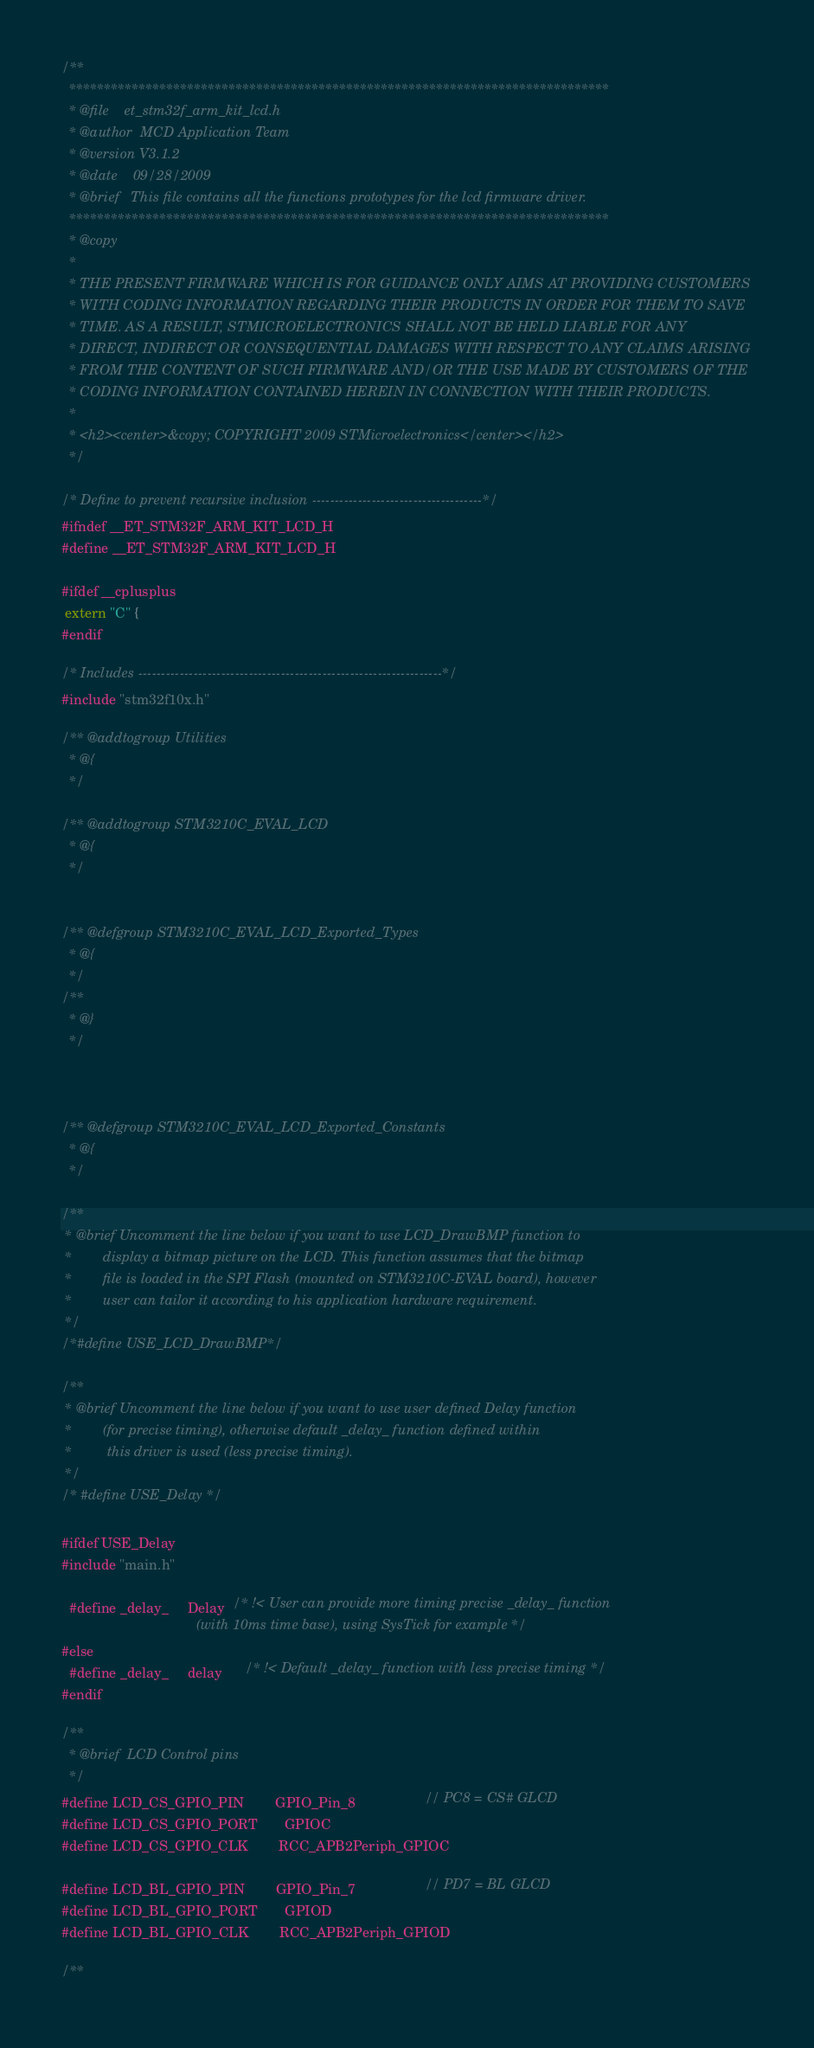Convert code to text. <code><loc_0><loc_0><loc_500><loc_500><_C_>/**
  ******************************************************************************
  * @file    et_stm32f_arm_kit_lcd.h
  * @author  MCD Application Team
  * @version V3.1.2
  * @date    09/28/2009
  * @brief   This file contains all the functions prototypes for the lcd firmware driver.
  ******************************************************************************
  * @copy
  *
  * THE PRESENT FIRMWARE WHICH IS FOR GUIDANCE ONLY AIMS AT PROVIDING CUSTOMERS
  * WITH CODING INFORMATION REGARDING THEIR PRODUCTS IN ORDER FOR THEM TO SAVE
  * TIME. AS A RESULT, STMICROELECTRONICS SHALL NOT BE HELD LIABLE FOR ANY
  * DIRECT, INDIRECT OR CONSEQUENTIAL DAMAGES WITH RESPECT TO ANY CLAIMS ARISING
  * FROM THE CONTENT OF SUCH FIRMWARE AND/OR THE USE MADE BY CUSTOMERS OF THE
  * CODING INFORMATION CONTAINED HEREIN IN CONNECTION WITH THEIR PRODUCTS.
  *
  * <h2><center>&copy; COPYRIGHT 2009 STMicroelectronics</center></h2>
  */ 

/* Define to prevent recursive inclusion -------------------------------------*/
#ifndef __ET_STM32F_ARM_KIT_LCD_H
#define __ET_STM32F_ARM_KIT_LCD_H

#ifdef __cplusplus
 extern "C" {
#endif

/* Includes ------------------------------------------------------------------*/
#include "stm32f10x.h"

/** @addtogroup Utilities
  * @{
  */
  
/** @addtogroup STM3210C_EVAL_LCD
  * @{
  */ 


/** @defgroup STM3210C_EVAL_LCD_Exported_Types
  * @{
  */ 
/**
  * @}
  */ 



/** @defgroup STM3210C_EVAL_LCD_Exported_Constants
  * @{
  */ 

/**
 * @brief Uncomment the line below if you want to use LCD_DrawBMP function to
 *        display a bitmap picture on the LCD. This function assumes that the bitmap
 *        file is loaded in the SPI Flash (mounted on STM3210C-EVAL board), however
 *        user can tailor it according to his application hardware requirement.     
 */
/*#define USE_LCD_DrawBMP*/

/**
 * @brief Uncomment the line below if you want to use user defined Delay function
 *        (for precise timing), otherwise default _delay_ function defined within
 *         this driver is used (less precise timing).  
 */
/* #define USE_Delay */

#ifdef USE_Delay
#include "main.h"
 
  #define _delay_     Delay  /* !< User can provide more timing precise _delay_ function
                                   (with 10ms time base), using SysTick for example */
#else
  #define _delay_     delay      /* !< Default _delay_ function with less precise timing */
#endif 

/** 
  * @brief  LCD Control pins  
  */ 
#define LCD_CS_GPIO_PIN        GPIO_Pin_8                  // PC8 = CS# GLCD
#define LCD_CS_GPIO_PORT       GPIOC                       
#define LCD_CS_GPIO_CLK        RCC_APB2Periph_GPIOC  

#define LCD_BL_GPIO_PIN        GPIO_Pin_7                  // PD7 = BL GLCD
#define LCD_BL_GPIO_PORT       GPIOD                       
#define LCD_BL_GPIO_CLK        RCC_APB2Periph_GPIOD 

/** </code> 